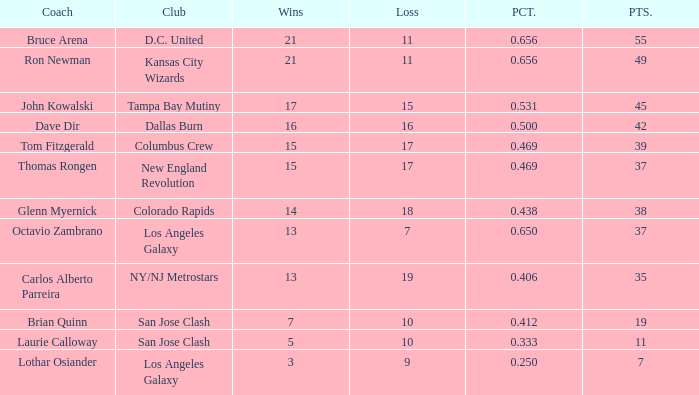What is the maximum percentage of bruce arena when he suffers over 11 losses? None. Parse the table in full. {'header': ['Coach', 'Club', 'Wins', 'Loss', 'PCT.', 'PTS.'], 'rows': [['Bruce Arena', 'D.C. United', '21', '11', '0.656', '55'], ['Ron Newman', 'Kansas City Wizards', '21', '11', '0.656', '49'], ['John Kowalski', 'Tampa Bay Mutiny', '17', '15', '0.531', '45'], ['Dave Dir', 'Dallas Burn', '16', '16', '0.500', '42'], ['Tom Fitzgerald', 'Columbus Crew', '15', '17', '0.469', '39'], ['Thomas Rongen', 'New England Revolution', '15', '17', '0.469', '37'], ['Glenn Myernick', 'Colorado Rapids', '14', '18', '0.438', '38'], ['Octavio Zambrano', 'Los Angeles Galaxy', '13', '7', '0.650', '37'], ['Carlos Alberto Parreira', 'NY/NJ Metrostars', '13', '19', '0.406', '35'], ['Brian Quinn', 'San Jose Clash', '7', '10', '0.412', '19'], ['Laurie Calloway', 'San Jose Clash', '5', '10', '0.333', '11'], ['Lothar Osiander', 'Los Angeles Galaxy', '3', '9', '0.250', '7']]} 